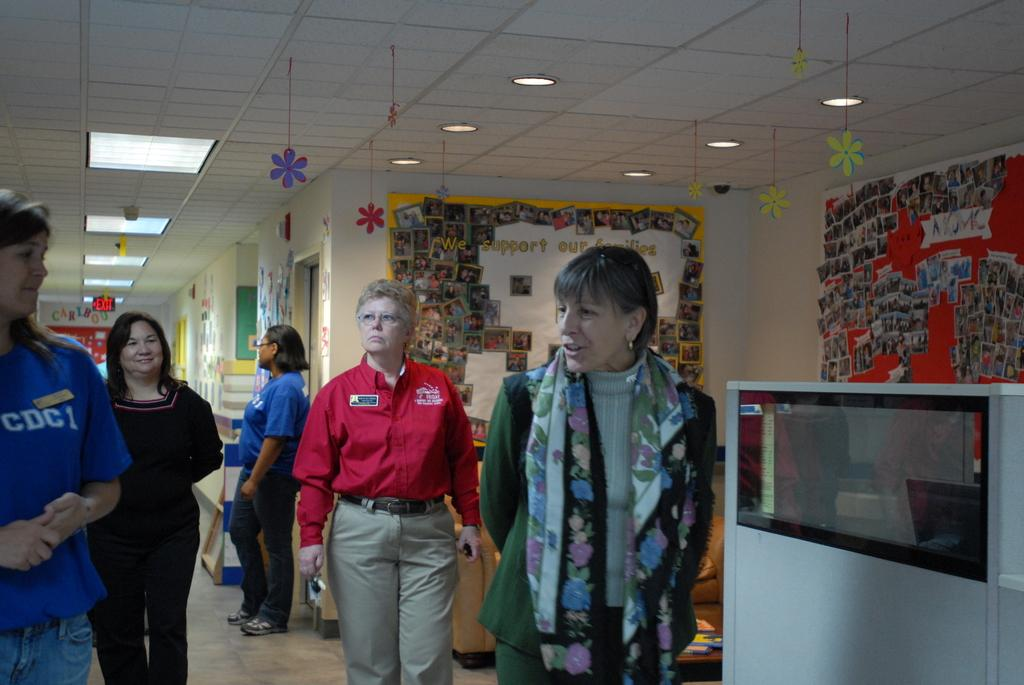<image>
Provide a brief description of the given image. a lady standing with others and wearing a CDC1 shirt 